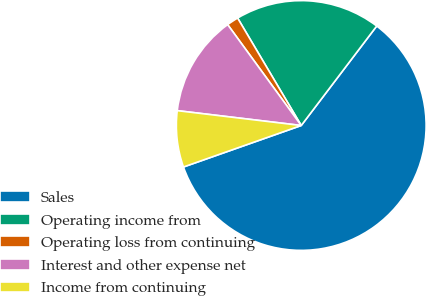<chart> <loc_0><loc_0><loc_500><loc_500><pie_chart><fcel>Sales<fcel>Operating income from<fcel>Operating loss from continuing<fcel>Interest and other expense net<fcel>Income from continuing<nl><fcel>59.27%<fcel>18.84%<fcel>1.52%<fcel>13.07%<fcel>7.29%<nl></chart> 